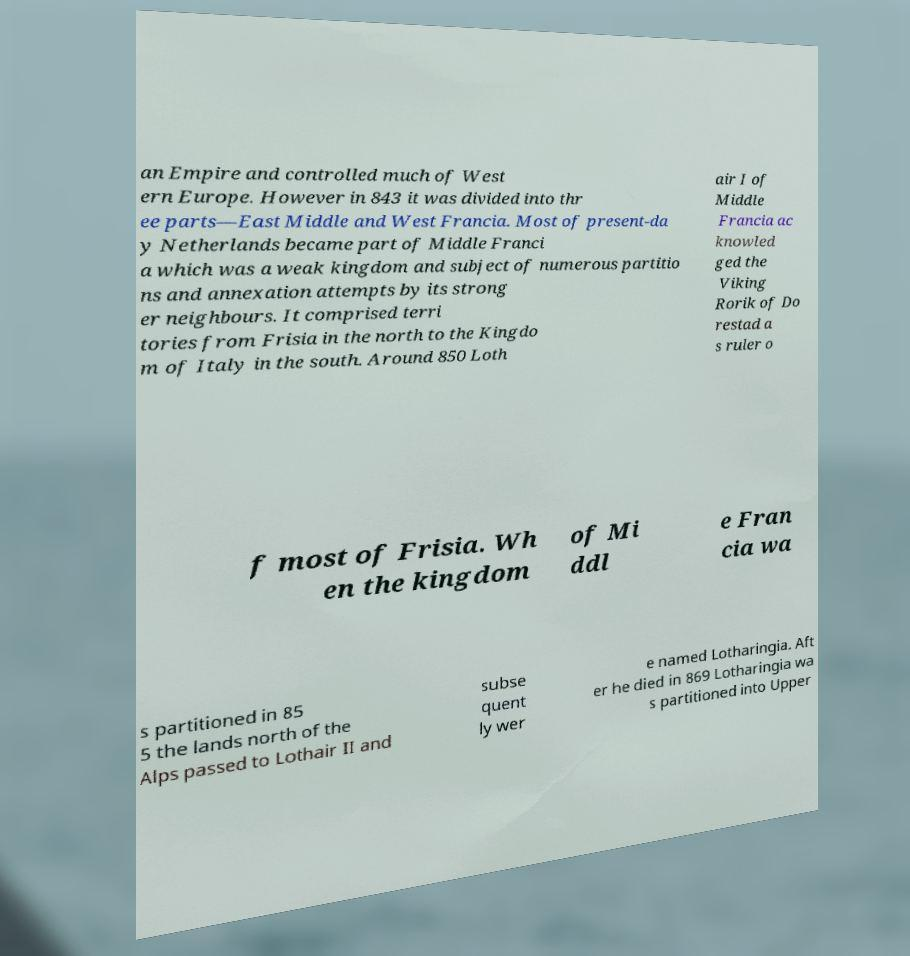For documentation purposes, I need the text within this image transcribed. Could you provide that? an Empire and controlled much of West ern Europe. However in 843 it was divided into thr ee parts—East Middle and West Francia. Most of present-da y Netherlands became part of Middle Franci a which was a weak kingdom and subject of numerous partitio ns and annexation attempts by its strong er neighbours. It comprised terri tories from Frisia in the north to the Kingdo m of Italy in the south. Around 850 Loth air I of Middle Francia ac knowled ged the Viking Rorik of Do restad a s ruler o f most of Frisia. Wh en the kingdom of Mi ddl e Fran cia wa s partitioned in 85 5 the lands north of the Alps passed to Lothair II and subse quent ly wer e named Lotharingia. Aft er he died in 869 Lotharingia wa s partitioned into Upper 